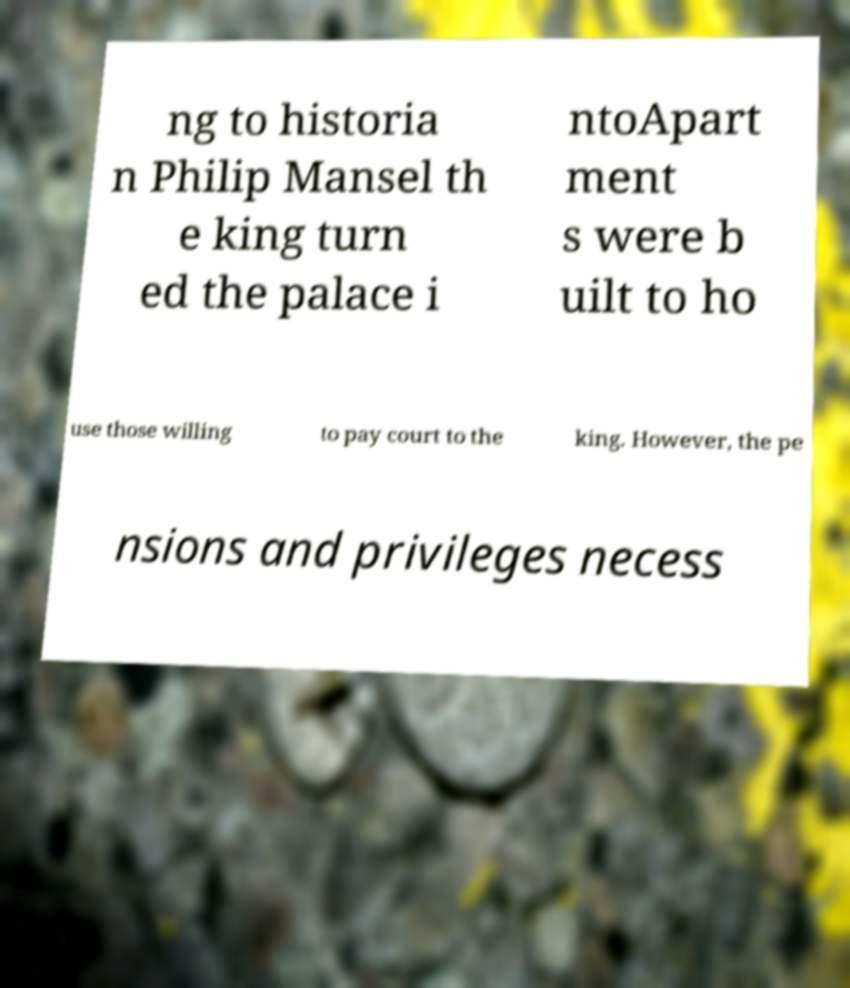Could you extract and type out the text from this image? ng to historia n Philip Mansel th e king turn ed the palace i ntoApart ment s were b uilt to ho use those willing to pay court to the king. However, the pe nsions and privileges necess 